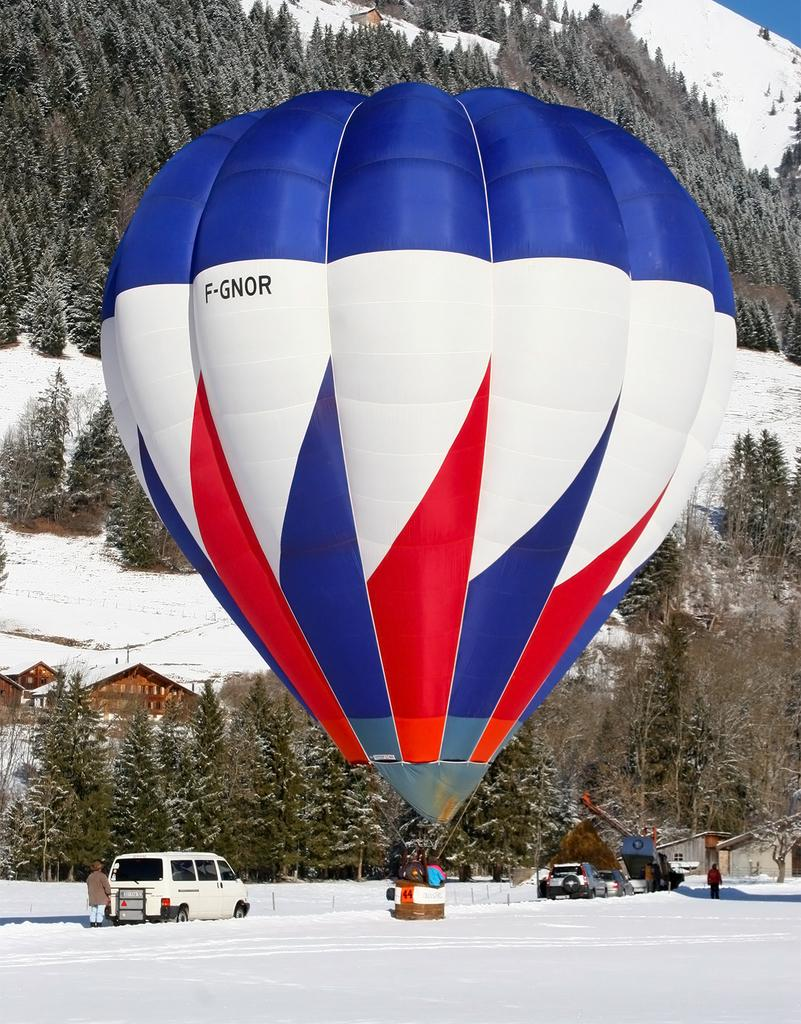Who or what can be seen in the image? There are people in the image. What are the people doing in the image? The people are likely engaging in activities related to the vehicles and para-shoot in the image. What is the terrain like in the image? The terrain includes snow and hills with trees. What else is present in the image besides people and the terrain? There are vehicles and a para-shoot in the image. What type of food is being sold in the store in the image? There is no store present in the image, so it is not possible to determine what type of food might be sold there. 